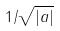<formula> <loc_0><loc_0><loc_500><loc_500>1 / \sqrt { | a | }</formula> 